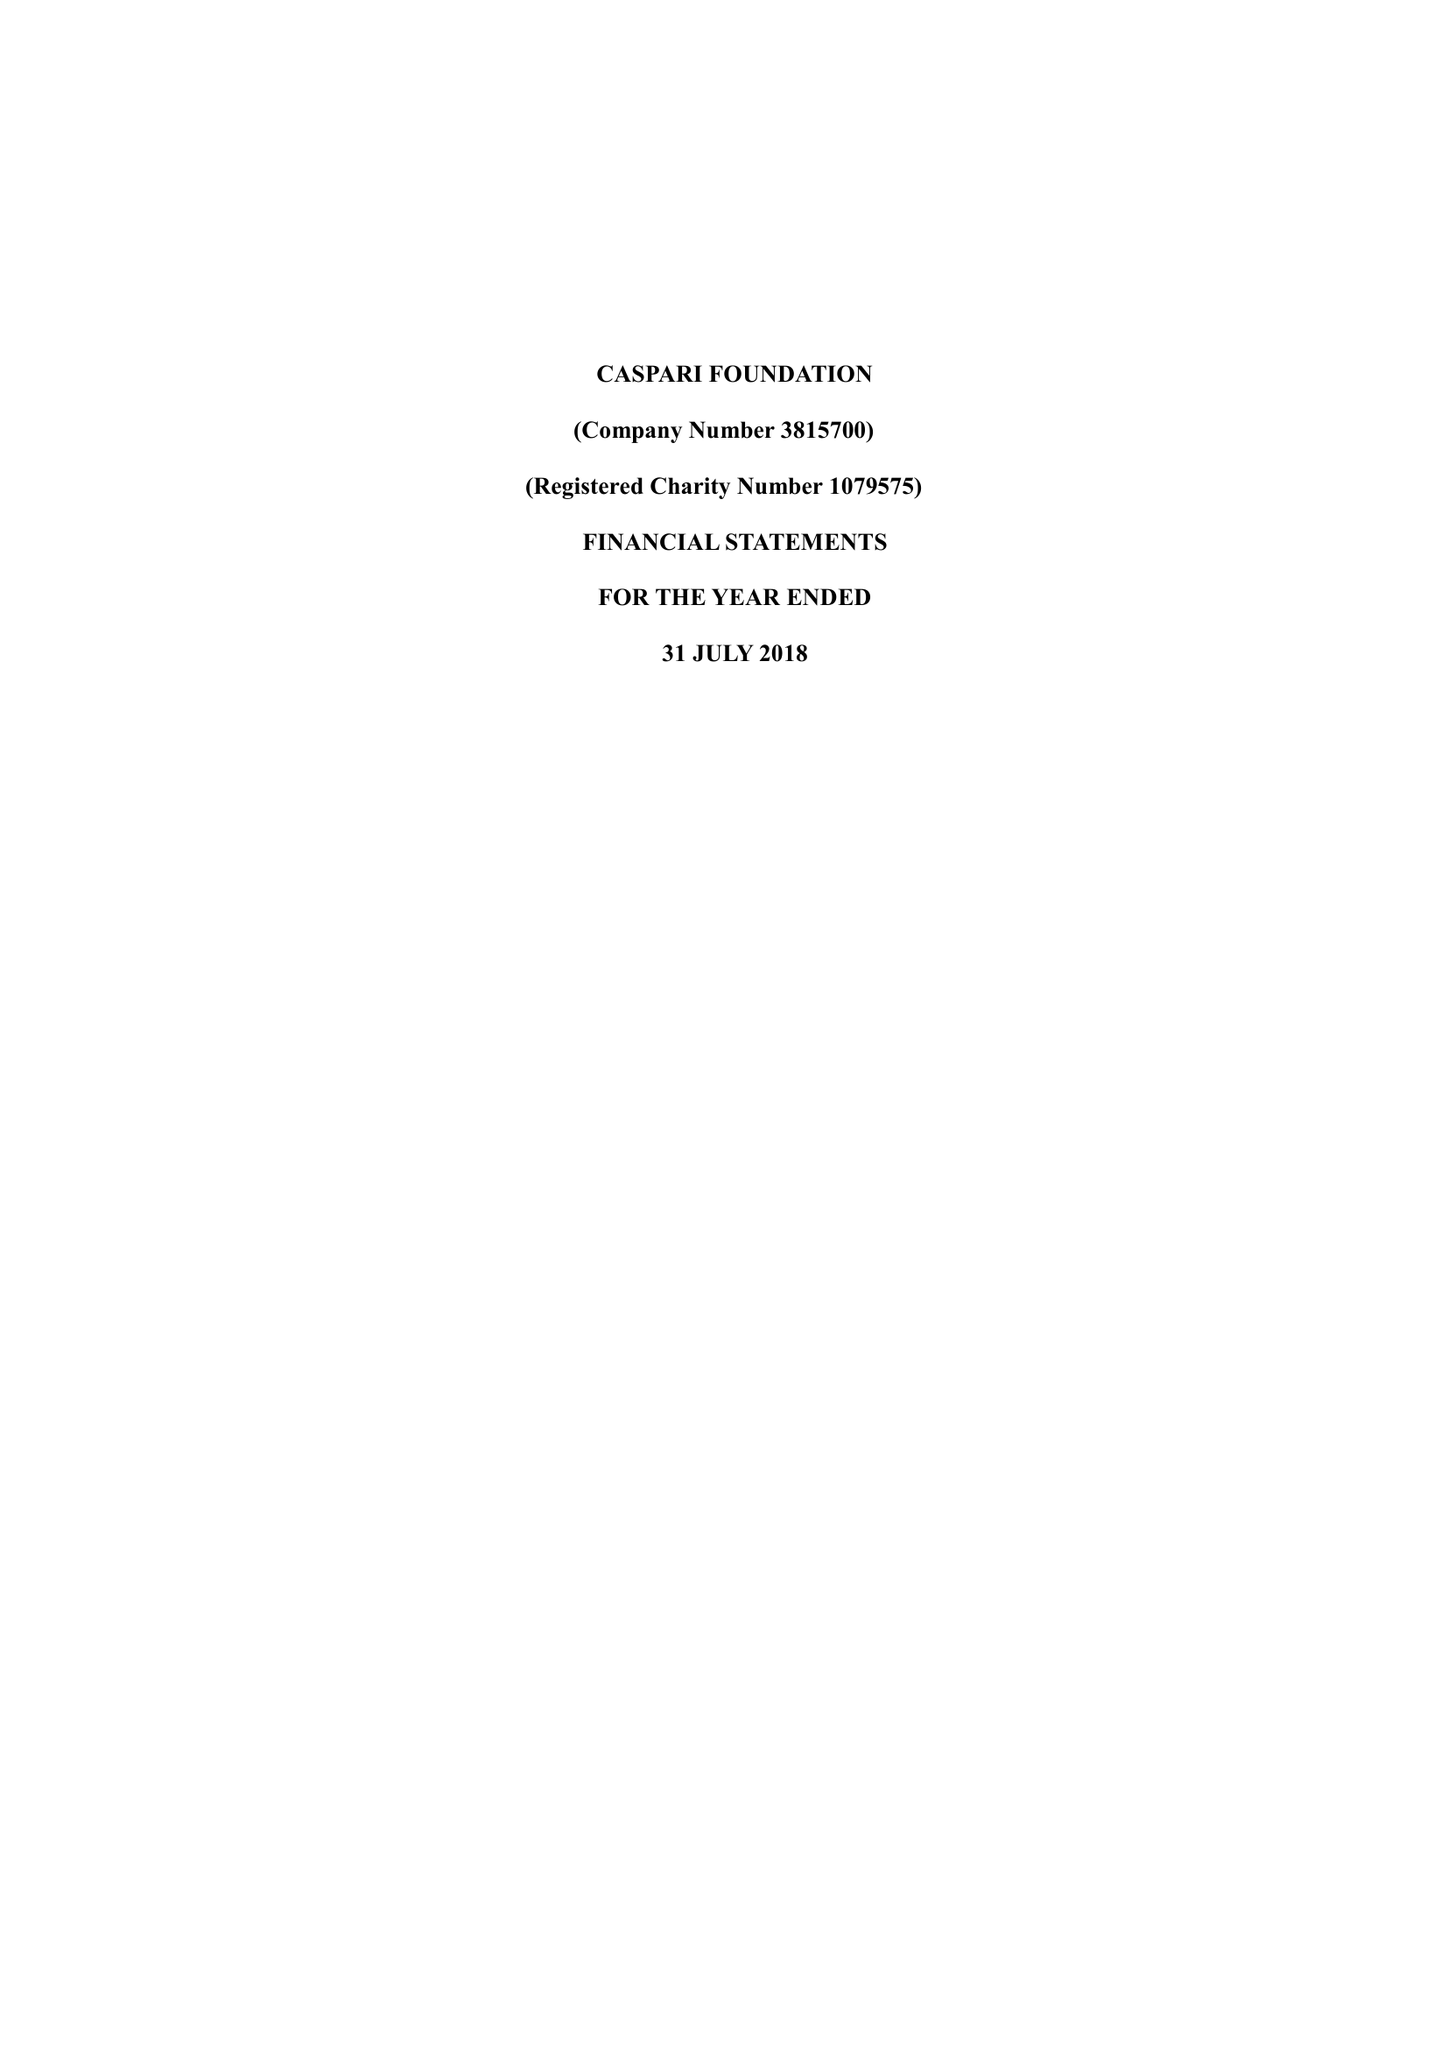What is the value for the spending_annually_in_british_pounds?
Answer the question using a single word or phrase. 189145.00 